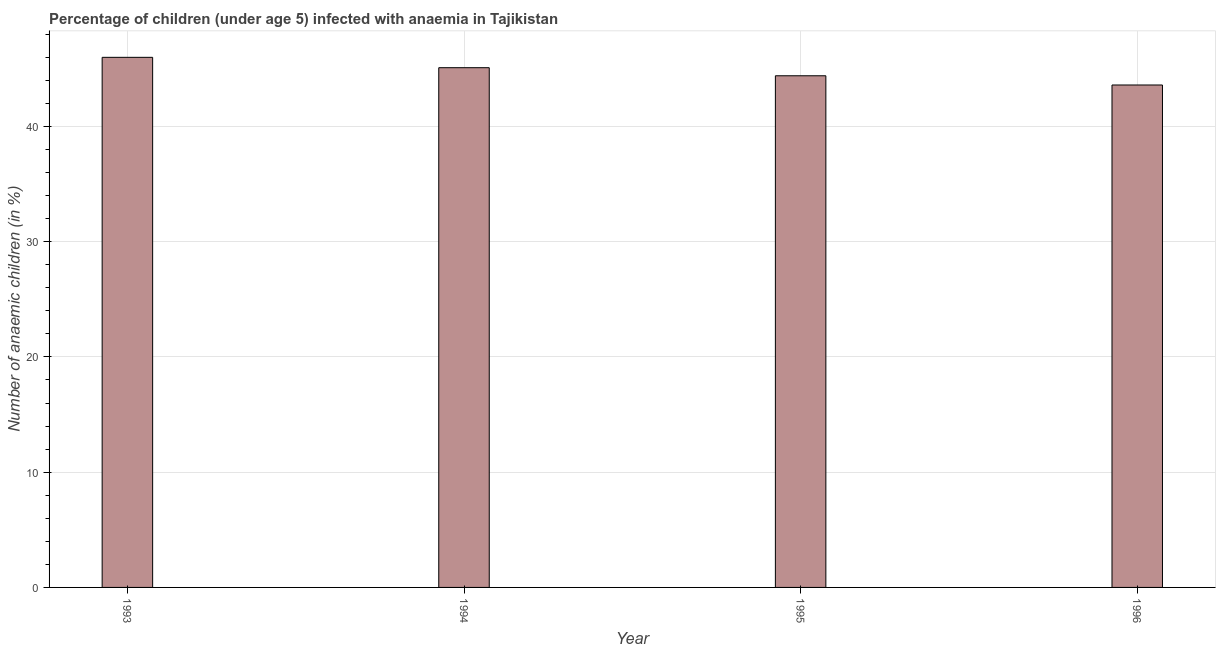Does the graph contain any zero values?
Provide a succinct answer. No. What is the title of the graph?
Give a very brief answer. Percentage of children (under age 5) infected with anaemia in Tajikistan. What is the label or title of the X-axis?
Ensure brevity in your answer.  Year. What is the label or title of the Y-axis?
Ensure brevity in your answer.  Number of anaemic children (in %). What is the number of anaemic children in 1993?
Your answer should be very brief. 46. Across all years, what is the minimum number of anaemic children?
Give a very brief answer. 43.6. In which year was the number of anaemic children maximum?
Provide a succinct answer. 1993. In which year was the number of anaemic children minimum?
Make the answer very short. 1996. What is the sum of the number of anaemic children?
Your response must be concise. 179.1. What is the average number of anaemic children per year?
Keep it short and to the point. 44.77. What is the median number of anaemic children?
Make the answer very short. 44.75. What is the difference between the highest and the second highest number of anaemic children?
Provide a short and direct response. 0.9. Is the sum of the number of anaemic children in 1994 and 1995 greater than the maximum number of anaemic children across all years?
Provide a succinct answer. Yes. How many bars are there?
Your answer should be compact. 4. What is the difference between two consecutive major ticks on the Y-axis?
Provide a succinct answer. 10. Are the values on the major ticks of Y-axis written in scientific E-notation?
Provide a succinct answer. No. What is the Number of anaemic children (in %) in 1993?
Your response must be concise. 46. What is the Number of anaemic children (in %) of 1994?
Your answer should be very brief. 45.1. What is the Number of anaemic children (in %) in 1995?
Ensure brevity in your answer.  44.4. What is the Number of anaemic children (in %) of 1996?
Your response must be concise. 43.6. What is the difference between the Number of anaemic children (in %) in 1993 and 1994?
Your response must be concise. 0.9. What is the difference between the Number of anaemic children (in %) in 1993 and 1995?
Provide a succinct answer. 1.6. What is the difference between the Number of anaemic children (in %) in 1994 and 1996?
Give a very brief answer. 1.5. What is the ratio of the Number of anaemic children (in %) in 1993 to that in 1995?
Your answer should be compact. 1.04. What is the ratio of the Number of anaemic children (in %) in 1993 to that in 1996?
Your answer should be very brief. 1.05. What is the ratio of the Number of anaemic children (in %) in 1994 to that in 1996?
Ensure brevity in your answer.  1.03. What is the ratio of the Number of anaemic children (in %) in 1995 to that in 1996?
Keep it short and to the point. 1.02. 